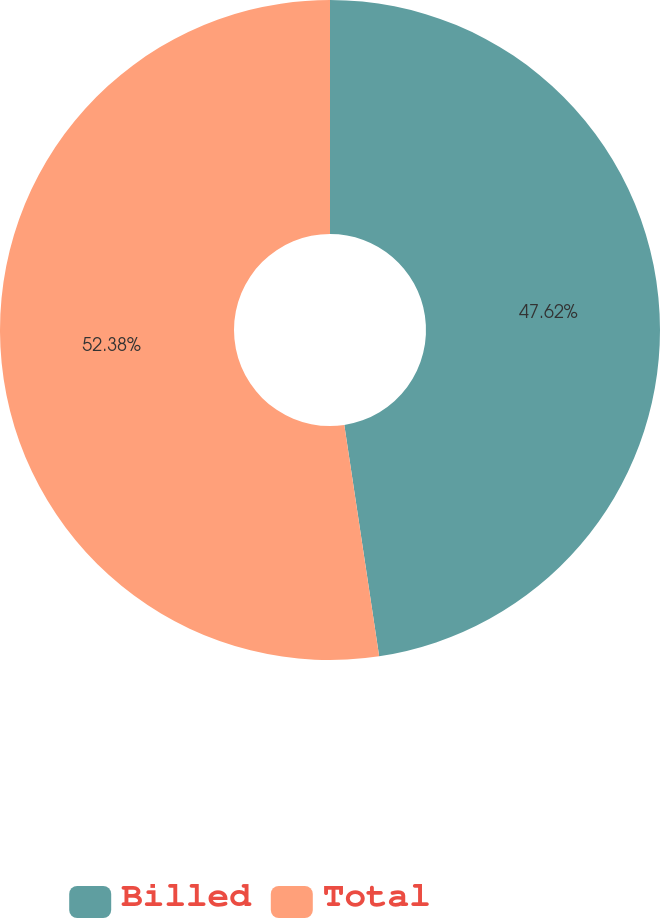Convert chart. <chart><loc_0><loc_0><loc_500><loc_500><pie_chart><fcel>Billed<fcel>Total<nl><fcel>47.62%<fcel>52.38%<nl></chart> 